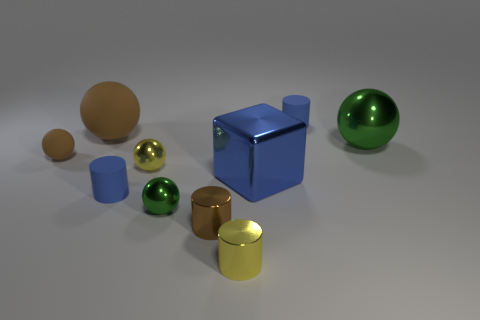Subtract all gray cubes. How many green spheres are left? 2 Subtract all yellow balls. How many balls are left? 4 Subtract 1 cylinders. How many cylinders are left? 3 Subtract all yellow spheres. How many spheres are left? 4 Subtract all cubes. How many objects are left? 9 Subtract all brown cylinders. Subtract all yellow balls. How many cylinders are left? 3 Add 2 big green shiny cubes. How many big green shiny cubes exist? 2 Subtract 0 gray blocks. How many objects are left? 10 Subtract all metallic cubes. Subtract all large objects. How many objects are left? 6 Add 8 blue blocks. How many blue blocks are left? 9 